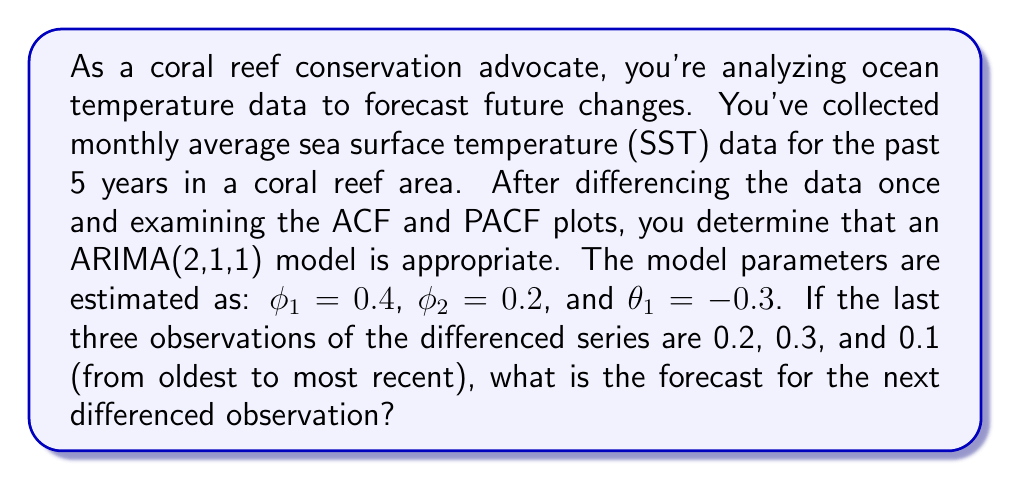Give your solution to this math problem. To forecast the next differenced observation using an ARIMA(2,1,1) model, we need to use the following equation:

$$y_t = \phi_1 y_{t-1} + \phi_2 y_{t-2} + \epsilon_t - \theta_1 \epsilon_{t-1}$$

Where:
- $y_t$ is the differenced observation at time $t$
- $\phi_1$ and $\phi_2$ are the autoregressive parameters
- $\theta_1$ is the moving average parameter
- $\epsilon_t$ is the error term at time $t$

Given:
- $\phi_1 = 0.4$
- $\phi_2 = 0.2$
- $\theta_1 = -0.3$
- Last three observations: $y_{t-2} = 0.2$, $y_{t-1} = 0.3$, $y_t = 0.1$

To forecast $y_{t+1}$, we need to:
1. Use the given equation
2. Substitute the known values
3. Estimate $\epsilon_t$ as the most recent observation minus its forecast
4. Assume $\epsilon_{t+1} = 0$ for the forecast

Step 1: Estimate $\epsilon_t$
Forecast for $y_t$: 
$$y_t = 0.4(0.3) + 0.2(0.2) + 0 - (-0.3)(0) = 0.16$$

$\epsilon_t = 0.1 - 0.16 = -0.06$

Step 2: Forecast $y_{t+1}$
$$y_{t+1} = 0.4(0.1) + 0.2(0.3) + 0 - (-0.3)(-0.06)$$
$$y_{t+1} = 0.04 + 0.06 + 0.018 = 0.118$$

Therefore, the forecast for the next differenced observation is approximately 0.118.
Answer: 0.118 